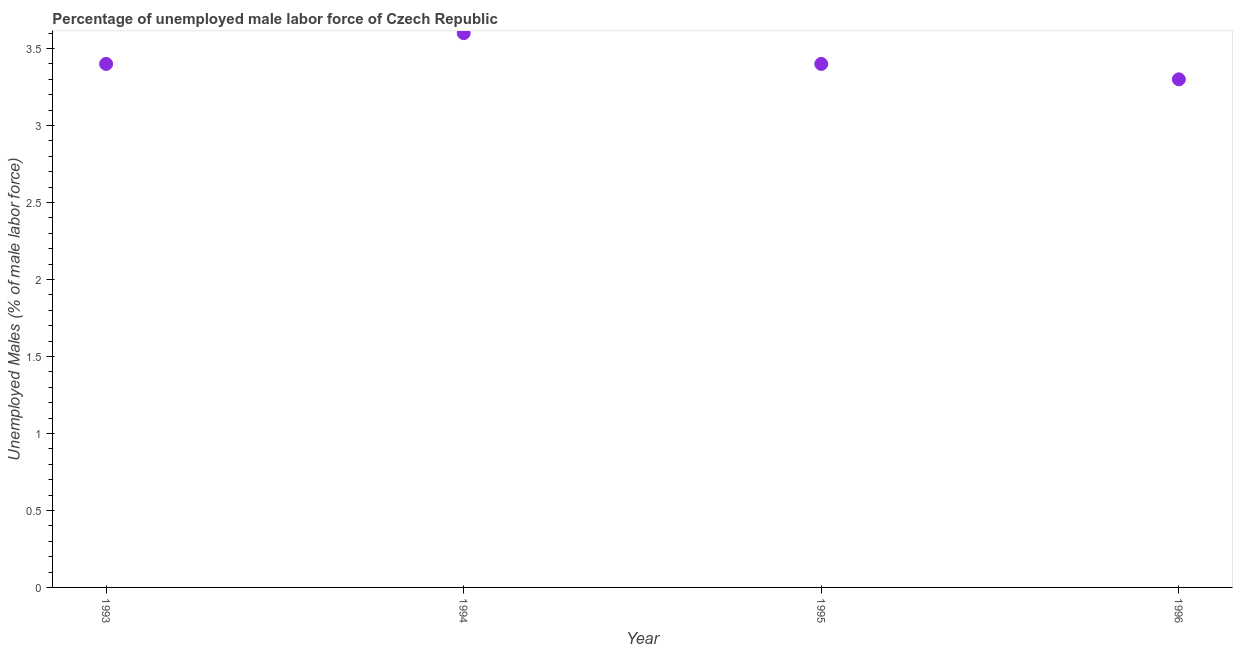What is the total unemployed male labour force in 1996?
Your answer should be compact. 3.3. Across all years, what is the maximum total unemployed male labour force?
Provide a short and direct response. 3.6. Across all years, what is the minimum total unemployed male labour force?
Ensure brevity in your answer.  3.3. In which year was the total unemployed male labour force minimum?
Your answer should be very brief. 1996. What is the sum of the total unemployed male labour force?
Your response must be concise. 13.7. What is the difference between the total unemployed male labour force in 1993 and 1996?
Offer a terse response. 0.1. What is the average total unemployed male labour force per year?
Ensure brevity in your answer.  3.43. What is the median total unemployed male labour force?
Offer a very short reply. 3.4. What is the ratio of the total unemployed male labour force in 1993 to that in 1994?
Your answer should be very brief. 0.94. Is the difference between the total unemployed male labour force in 1993 and 1995 greater than the difference between any two years?
Your answer should be very brief. No. What is the difference between the highest and the second highest total unemployed male labour force?
Your response must be concise. 0.2. What is the difference between the highest and the lowest total unemployed male labour force?
Make the answer very short. 0.3. In how many years, is the total unemployed male labour force greater than the average total unemployed male labour force taken over all years?
Offer a very short reply. 1. How many years are there in the graph?
Provide a succinct answer. 4. What is the difference between two consecutive major ticks on the Y-axis?
Your answer should be compact. 0.5. Are the values on the major ticks of Y-axis written in scientific E-notation?
Make the answer very short. No. Does the graph contain grids?
Your answer should be compact. No. What is the title of the graph?
Provide a short and direct response. Percentage of unemployed male labor force of Czech Republic. What is the label or title of the X-axis?
Offer a very short reply. Year. What is the label or title of the Y-axis?
Provide a succinct answer. Unemployed Males (% of male labor force). What is the Unemployed Males (% of male labor force) in 1993?
Offer a very short reply. 3.4. What is the Unemployed Males (% of male labor force) in 1994?
Keep it short and to the point. 3.6. What is the Unemployed Males (% of male labor force) in 1995?
Provide a short and direct response. 3.4. What is the Unemployed Males (% of male labor force) in 1996?
Make the answer very short. 3.3. What is the difference between the Unemployed Males (% of male labor force) in 1993 and 1994?
Your answer should be compact. -0.2. What is the difference between the Unemployed Males (% of male labor force) in 1993 and 1996?
Keep it short and to the point. 0.1. What is the difference between the Unemployed Males (% of male labor force) in 1994 and 1995?
Give a very brief answer. 0.2. What is the difference between the Unemployed Males (% of male labor force) in 1994 and 1996?
Ensure brevity in your answer.  0.3. What is the difference between the Unemployed Males (% of male labor force) in 1995 and 1996?
Offer a very short reply. 0.1. What is the ratio of the Unemployed Males (% of male labor force) in 1993 to that in 1994?
Your answer should be compact. 0.94. What is the ratio of the Unemployed Males (% of male labor force) in 1993 to that in 1995?
Your response must be concise. 1. What is the ratio of the Unemployed Males (% of male labor force) in 1993 to that in 1996?
Provide a succinct answer. 1.03. What is the ratio of the Unemployed Males (% of male labor force) in 1994 to that in 1995?
Give a very brief answer. 1.06. What is the ratio of the Unemployed Males (% of male labor force) in 1994 to that in 1996?
Make the answer very short. 1.09. 